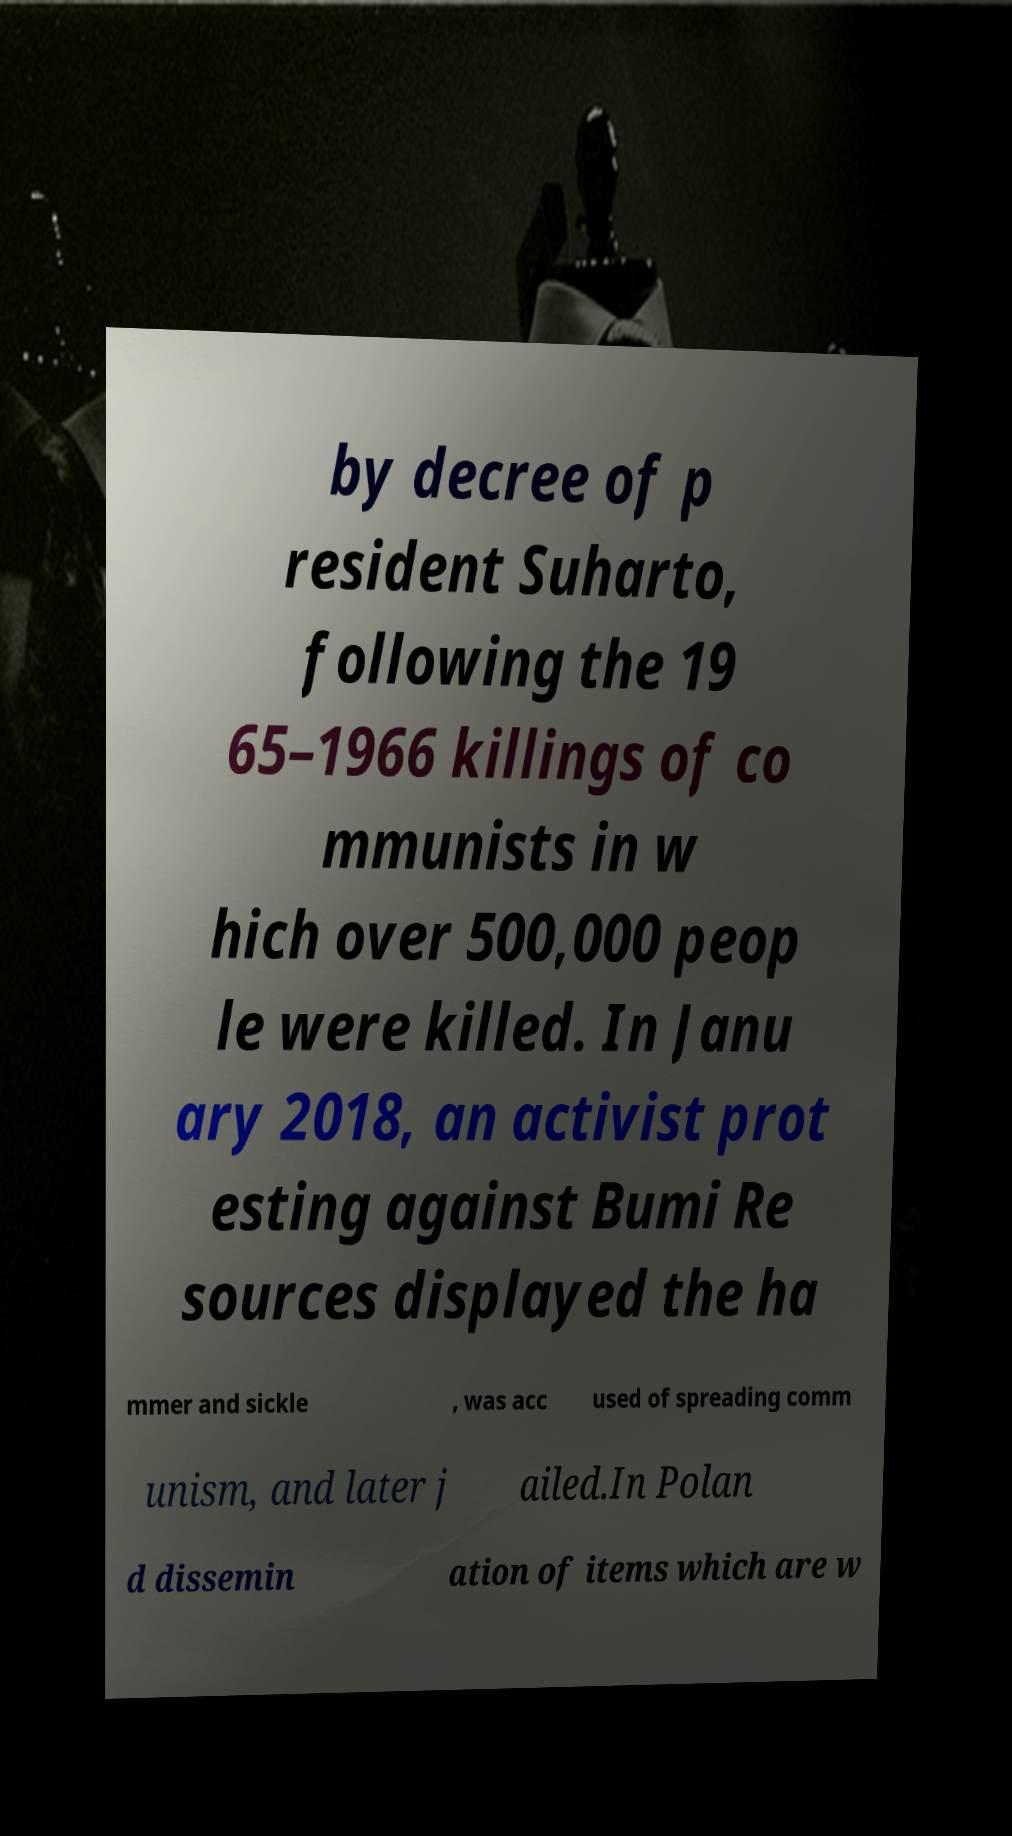Can you read and provide the text displayed in the image?This photo seems to have some interesting text. Can you extract and type it out for me? by decree of p resident Suharto, following the 19 65–1966 killings of co mmunists in w hich over 500,000 peop le were killed. In Janu ary 2018, an activist prot esting against Bumi Re sources displayed the ha mmer and sickle , was acc used of spreading comm unism, and later j ailed.In Polan d dissemin ation of items which are w 